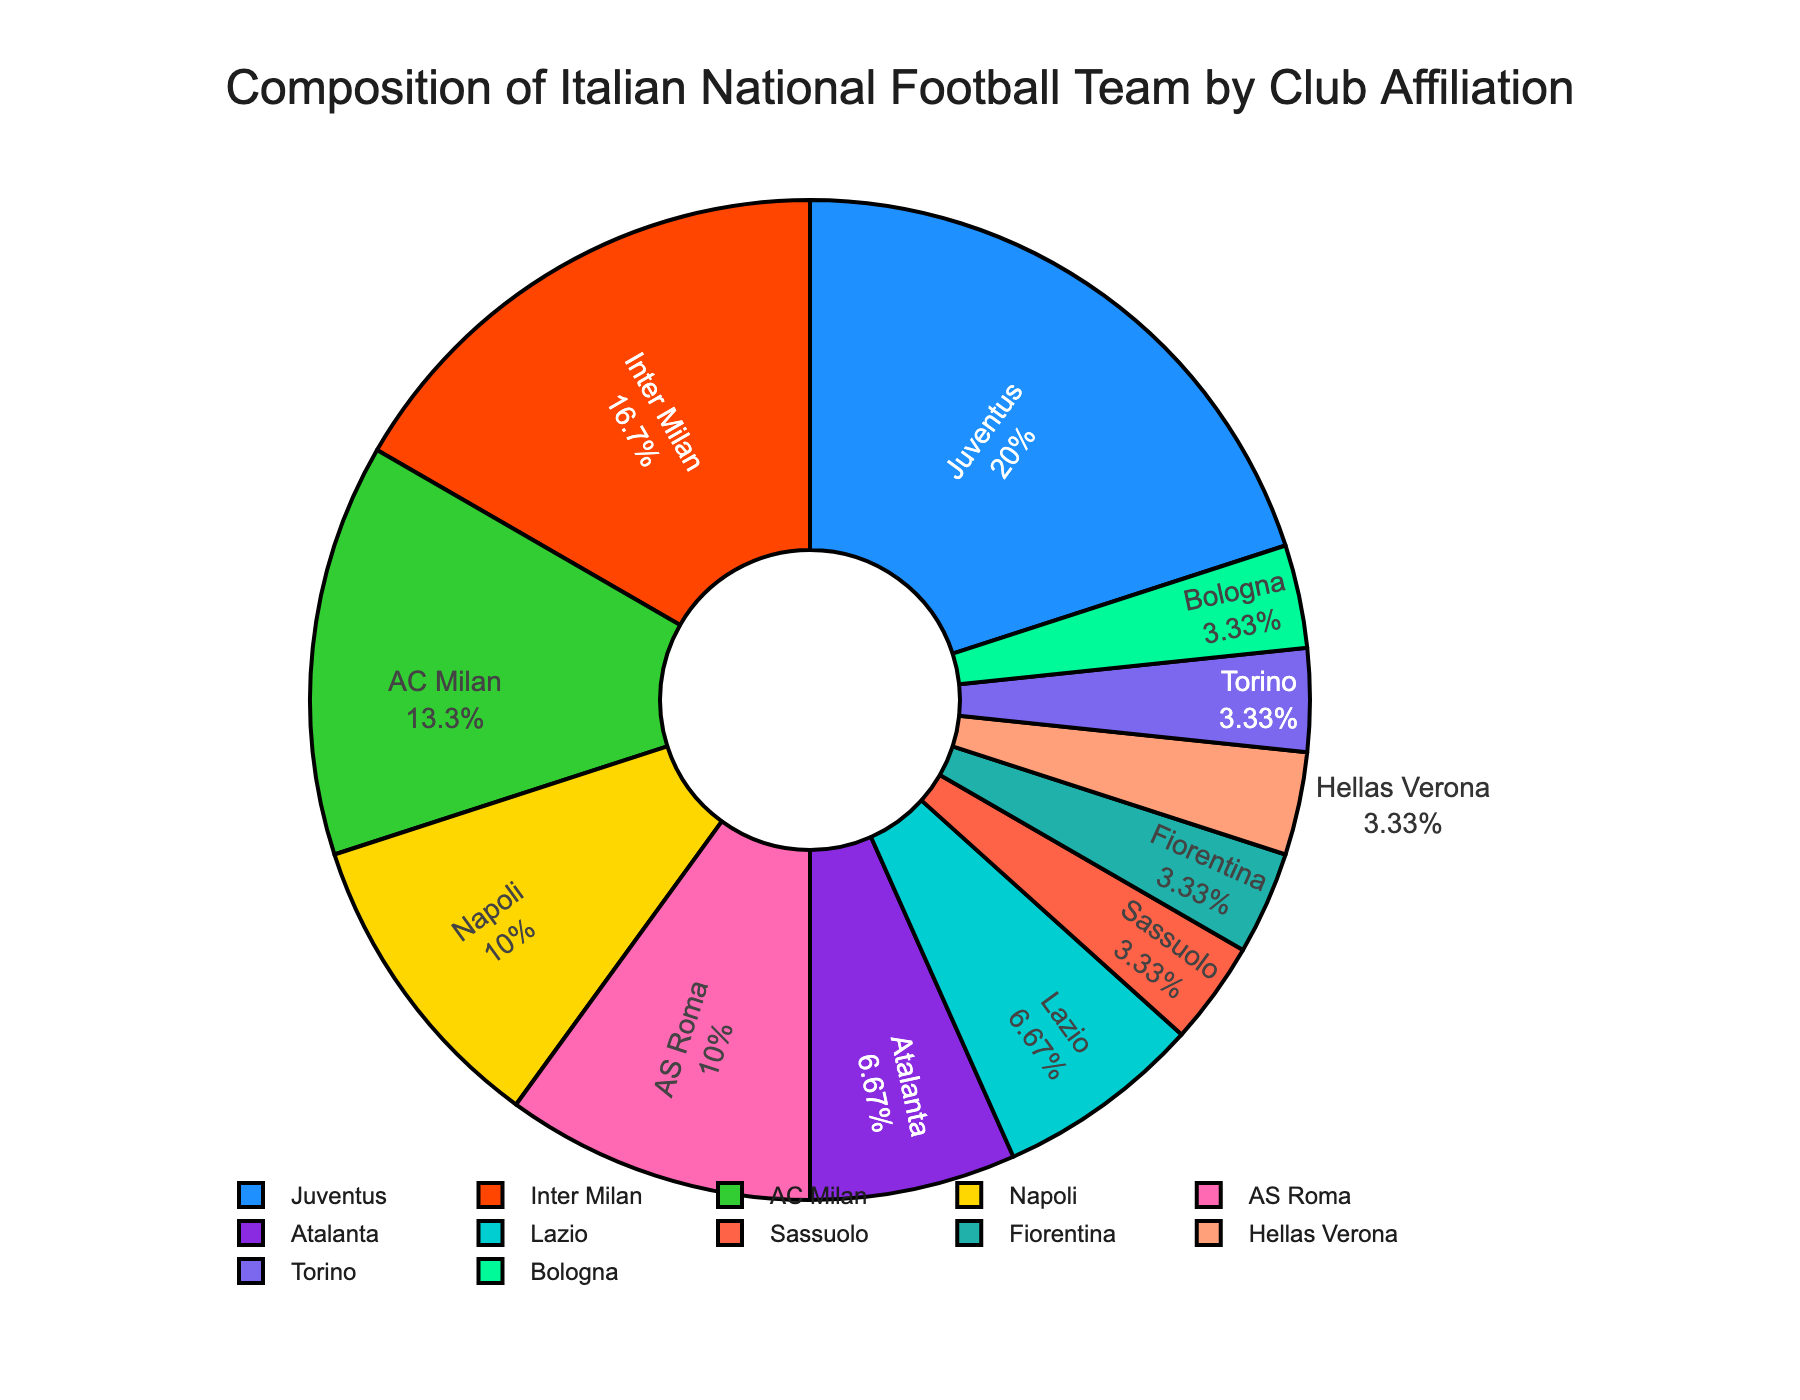Which club has the highest number of players in the Italian national team? By observing the pie chart, the club with the highest percentage of the pie will have the highest number of players. Look at the labels to identify the club corresponding to the largest segment.
Answer: Juventus How many more players does Juventus have compared to AS Roma? Identify the number of players each club has from the chart. Subtract the number of players of AS Roma from that of Juventus. The chart shows Juventus with 6 players and AS Roma with 3. So, 6 - 3 = 3.
Answer: 3 Which two clubs have an equal number of players in the Italian national team? Examine the pie chart for two segments with the same percentages or the same number of players in the labels. According to the data, both Napoli and AS Roma have 3 players each.
Answer: Napoli and AS Roma What is the percentage of players affiliated with Juventus, Inter Milan, and AC Milan combined? Add the individual percentages of each club from the chart. Juventus, Inter Milan, and AC Milan have 6, 5, and 4 players respectively. Calculate their combined percentage by summing their number of players and then dividing by the total number of players before converting to percentage: (6+5+4)/30 = 15/30 = 50%.
Answer: 50% Which club represents the smallest segment in the pie chart? Observe the chart to find the smallest segment. Identify the club label associated with that. The chart shows that several clubs have one player, but they are all the smallest, so any one of those clubs can fit.
Answer: Sassuolo (or any other with 1 player) Does Lazio have more or fewer players in the Italian national team than Atalanta? Compare the segments of Lazio and Atalanta. Lazio has 2 players while Atalanta also has 2 players.
Answer: Equal Out of the total number of players, what fraction comes from Inter Milan and AC Milan combined? Calculate the total number of players first (6+5+4+3+3+2+2+1+1+1+1+1 = 30). Sum the players from Inter Milan and AC Milan (5+4), which totals 9. Then, convert this number into a fraction of the total number: 9/30. Simplify the fraction if possible: 9/30 = 3/10.
Answer: 3/10 Which clubs have players representing a single-digit percentage of the Italian national team? Identify the segments that have less than 10% from the labeled chart. Clubs with 1 or 2 players will have single-digit percentages since 1/30 and 2/30 equal approximately 3.33% and 6.67% respectively.
Answer: Sassuolo, Fiorentina, Hellas Verona, Torino, Bologna What's the total number of affiliations represented by clubs with 3 or more players? Count the clubs that have 3 or more players, then sum their players. Clubs are: Juventus (6), Inter Milan (5), AC Milan (4), Napoli (3), and AS Roma (3). Sum them: 6+5+4+3+3 = 21.
Answer: 21 